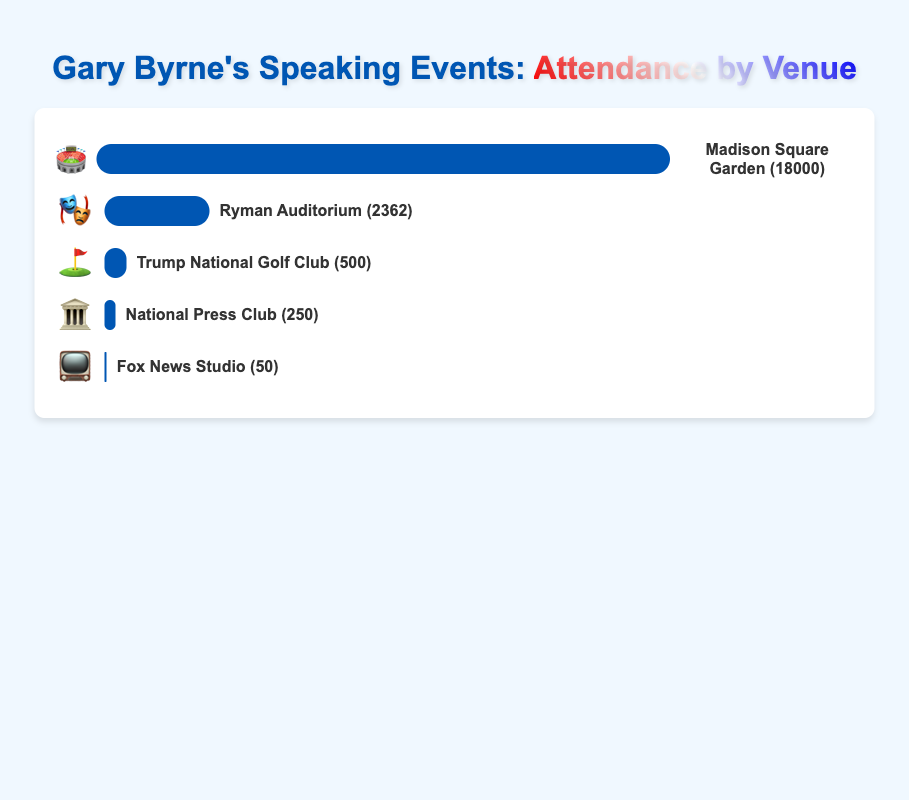What is the attendance at Madison Square Garden? According to the figure, the attendance at Madison Square Garden is shown next to the venue's name. It shows 18,000 with an emoji of a stadium.
Answer: 18,000 Which venue has the smallest attendance? The figure shows different venues with their respective attendance numbers. Fox News Studio has the smallest attendance at 50, indicated by the TV emoji.
Answer: Fox News Studio How many venues have an attendance of more than 2,000? From the figure, identify all venues with attendance numbers over 2,000. Madison Square Garden (18,000) and Ryman Auditorium (2,362) meet this criterion, so there are two venues.
Answer: 2 What is the average attendance across all venues? Sum the attendance numbers of all venues (18,000 + 2,362 + 250 + 50 + 500) to get 21,162. Divide this by the number of venues, which is 5. The calculation is 21,162 / 5 = 4,232.4.
Answer: 4,232.4 Which medium-sized venue has higher attendance, Ryman Auditorium or Trump National Golf Club? Compare the attendance numbers from the figure. Ryman Auditorium has 2,362 attendees, while Trump National Golf Club has 500 attendees. Therefore, Ryman Auditorium has higher attendance.
Answer: Ryman Auditorium What is the total attendance for all medium-sized venues? The medium-sized venues are Ryman Auditorium (2,362) and Trump National Golf Club (500). Sum their attendances: 2,362 + 500 = 2,862.
Answer: 2,862 Is there a significant difference between the attendance at Madison Square Garden and the National Press Club? Subtract the attendance of the National Press Club (250) from Madison Square Garden (18,000). The difference is 18,000 - 250 = 17,750, which is quite significant.
Answer: Yes Which venue has the highest attendance and what is its corresponding emoji? The venue with the highest attendance is Madison Square Garden with 18,000 attendees. Its corresponding emoji is a stadium (🏟️).
Answer: Madison Square Garden, 🏟️ Arrange the venues from highest to lowest attendance. Order the venues based on their attendance figures from highest to lowest: Madison Square Garden (18,000), Ryman Auditorium (2,362), Trump National Golf Club (500), National Press Club (250), Fox News Studio (50).
Answer: Madison Square Garden, Ryman Auditorium, Trump National Golf Club, National Press Club, Fox News Studio 